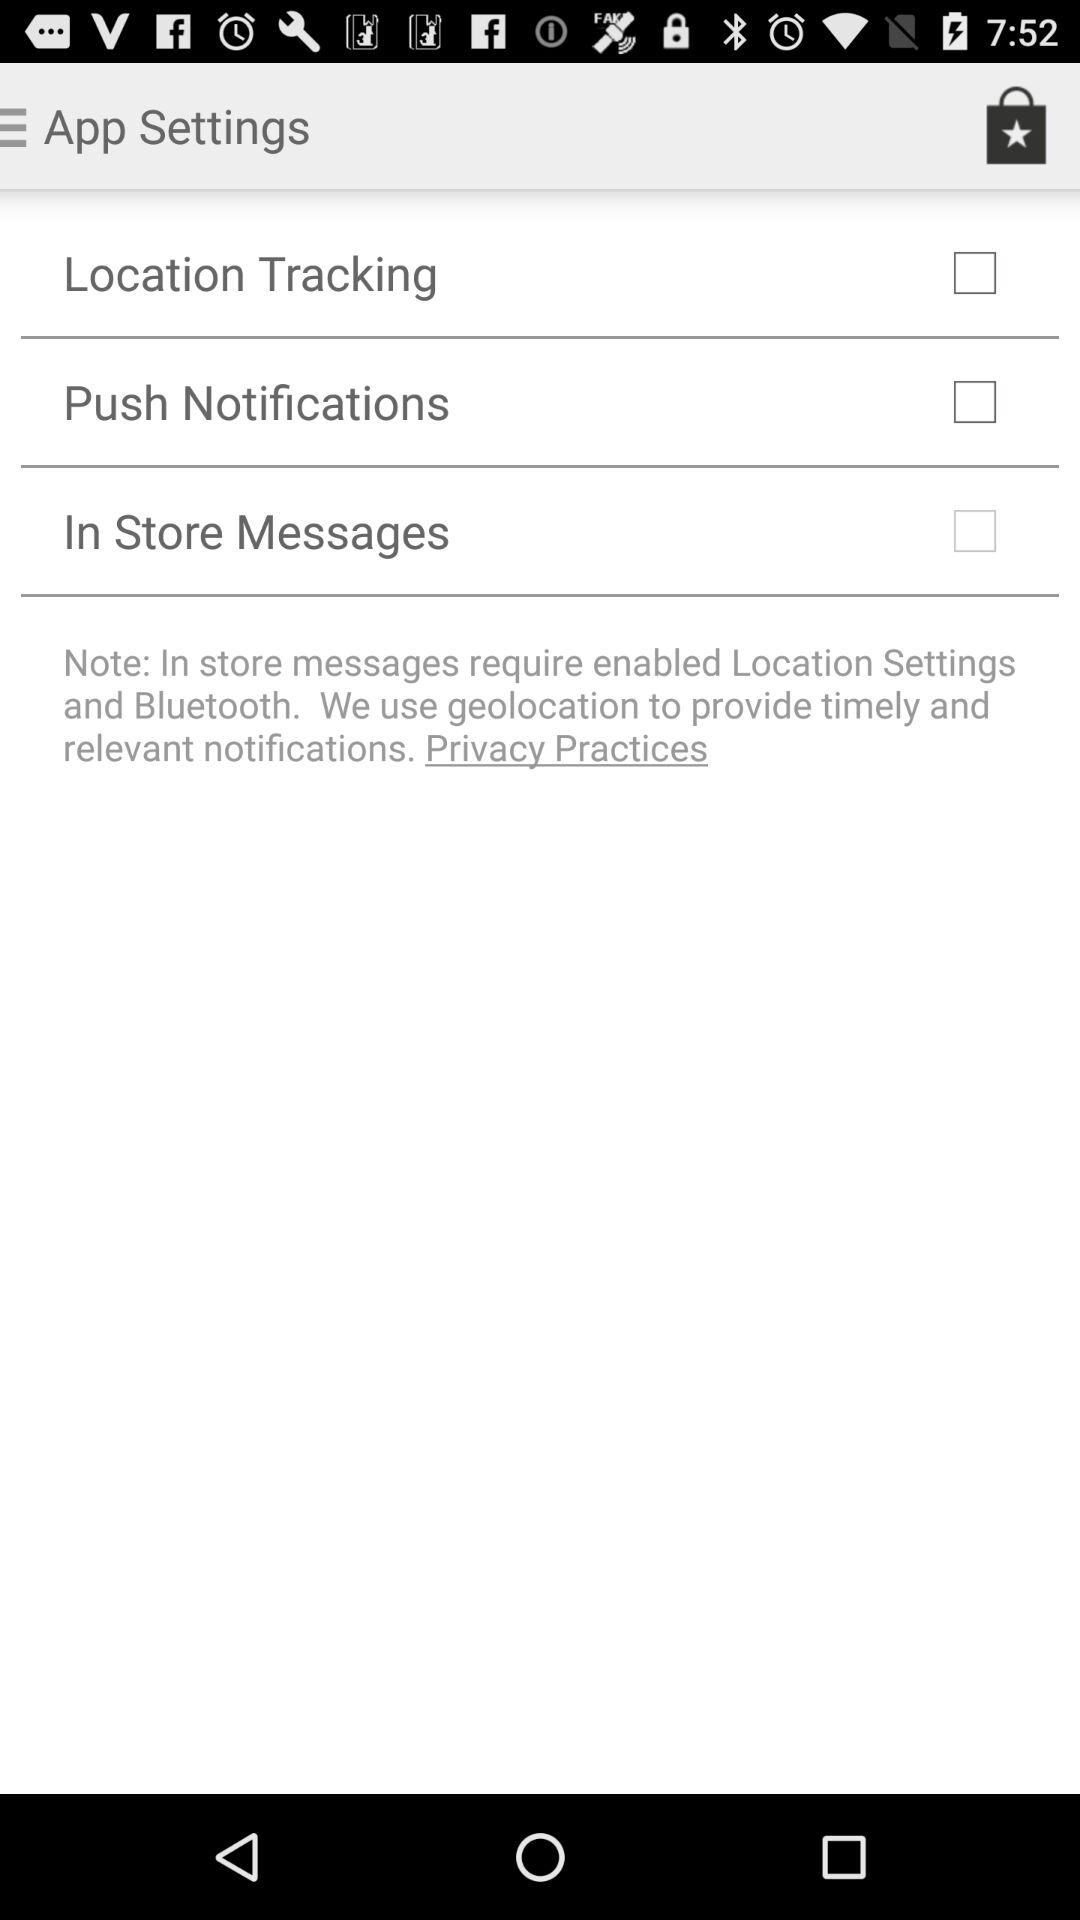What is the status of "Push Notifications"? The status is "off". 